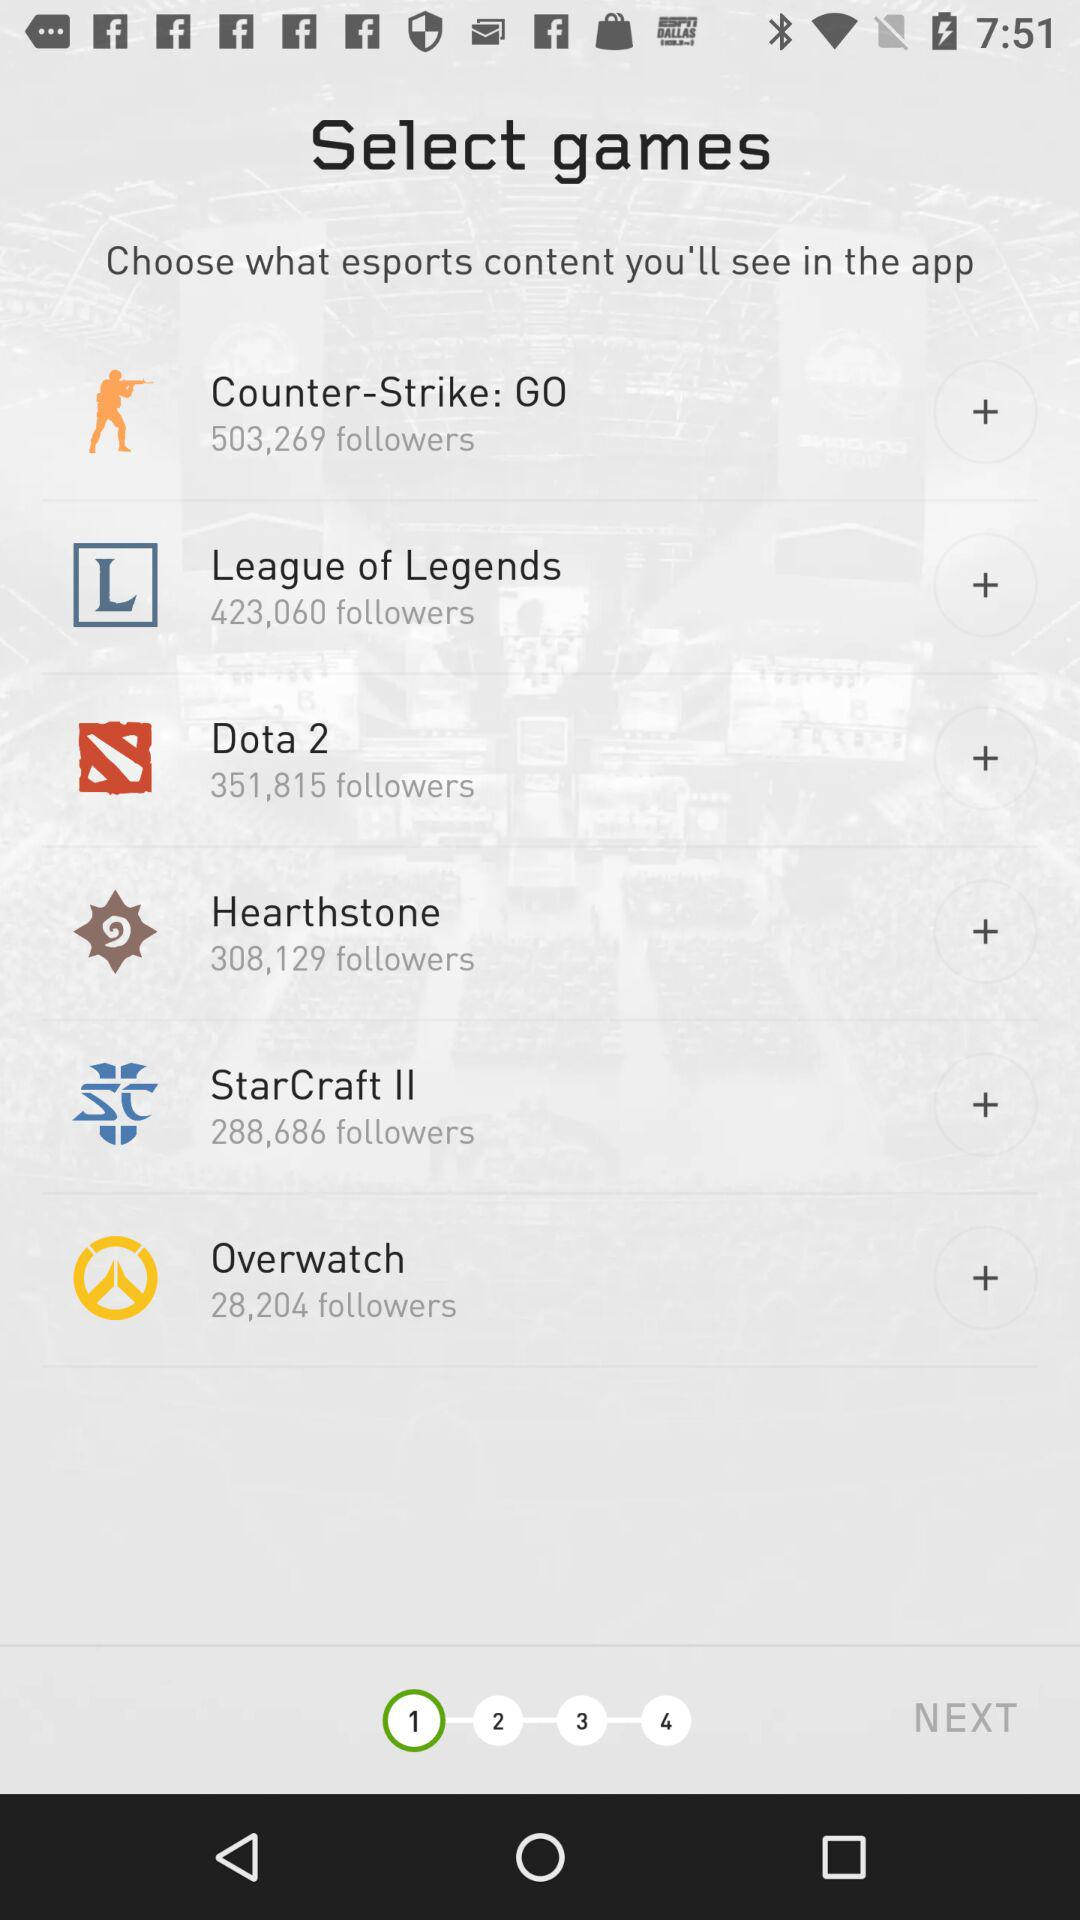How many followers does the game with the smallest number of followers have?
Answer the question using a single word or phrase. 28,204 